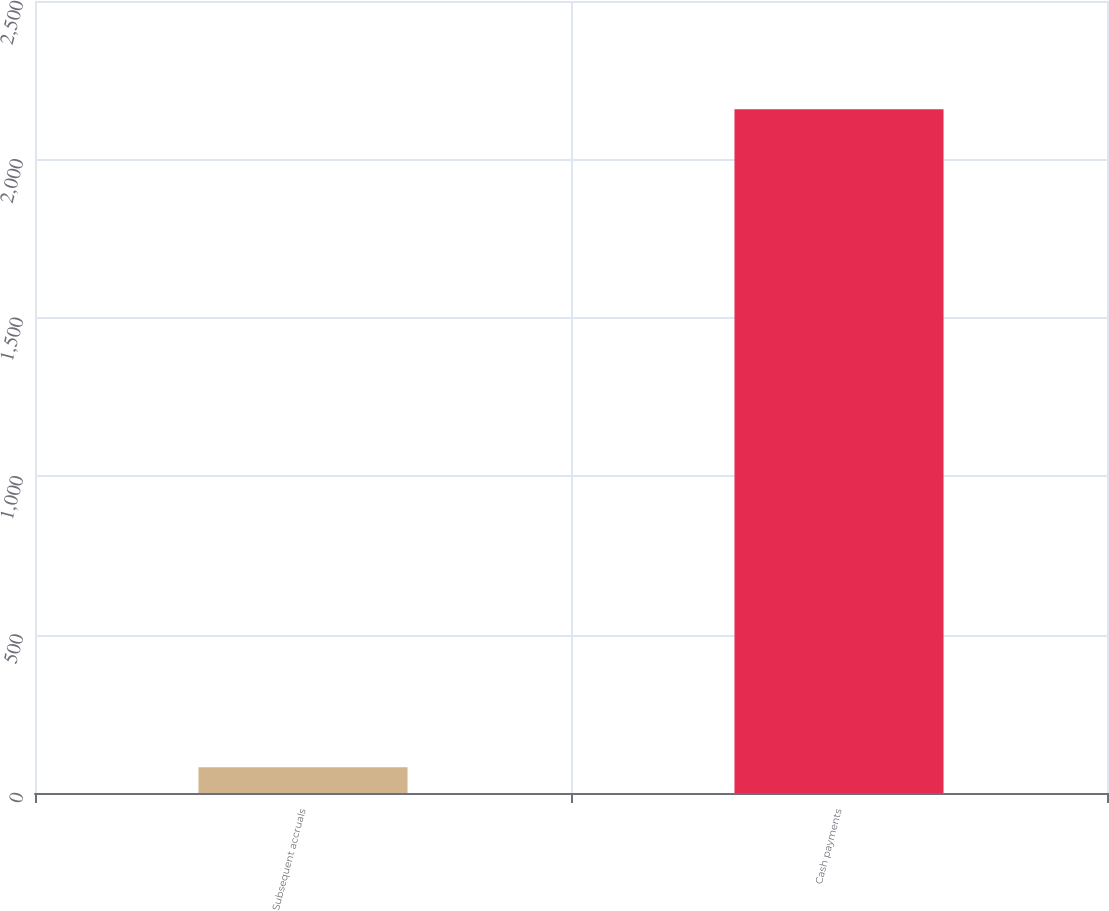<chart> <loc_0><loc_0><loc_500><loc_500><bar_chart><fcel>Subsequent accruals<fcel>Cash payments<nl><fcel>81<fcel>2158<nl></chart> 